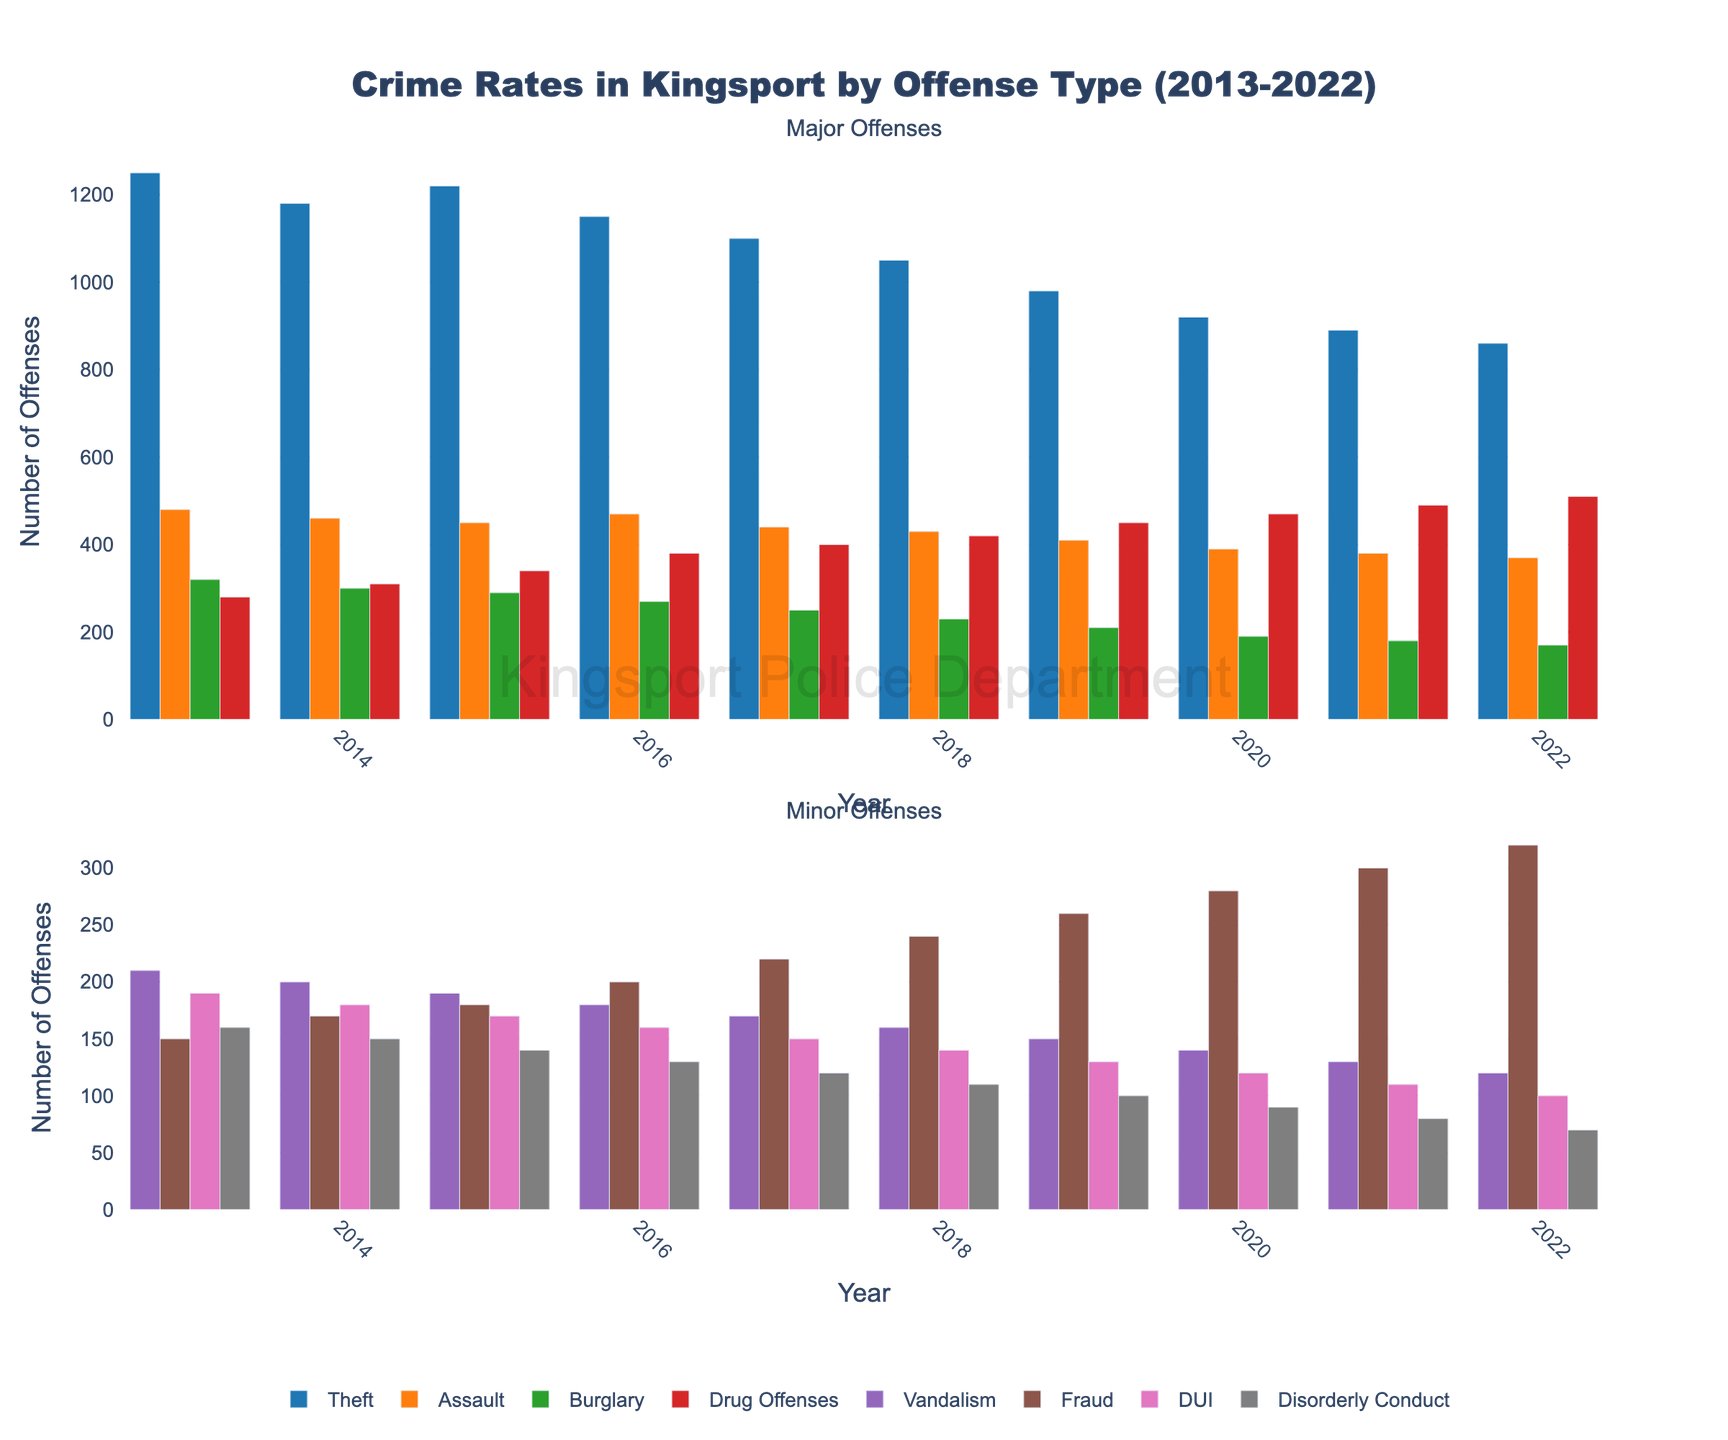What offense type saw the highest total number of offenses from 2013 to 2022? By summing the values for each year from 2013 to 2022 for every offense type, we find that 'Theft' has the highest total number of offenses.
Answer: Theft Which two offense types had the closest number of offenses in 2022? In 2022, the numbers of offenses are: Vandalism (120), Fraud (320), DUI (100), and Disorderly Conduct (70). Comparing these, 'DUI' (100) and 'Disorderly Conduct' (70) have the closest values with a difference of 30 offenses.
Answer: DUI and Disorderly Conduct How did the number of drug offenses change from 2013 to 2022? In 2013, there were 280 drug offenses; by 2022, there were 510. To find the change, subtract the earlier number from the later: 510 - 280 = 230, indicating an increase of 230 offenses.
Answer: Increased by 230 Which offense type showed a consistent decrease every year from 2013 to 2022? By examining each offense type year by year, 'Burglary' consistently decreased every single year from 320 offenses in 2013 to 170 in 2022.
Answer: Burglary In what year did Vandalism drop below 200 offenses for the first time? Observing the values for Vandalism, it dropped below 200 offenses for the first time in 2018, with 160 offenses.
Answer: 2018 What is the average number of DUI offenses over the decade? Sum the DUI values from each year: 190 + 180 + 170 + 160 + 150 + 140 + 130 + 120 + 110 + 100 = 1550. Divide this by the number of years (10): 1550 / 10 = 155.
Answer: 155 How much did the number of fraud offenses increase from 2013 to 2022? In 2013, there were 150 fraud offenses; in 2022, there were 320. Calculate the increase: 320 - 150 = 170.
Answer: Increased by 170 Which year had the highest combined number of major offenses (Theft, Assault, Burglary, Drug Offenses)? Sum the values for Theft, Assault, Burglary, and Drug Offenses for each year. 2013 has the highest combined total: 1250 (Theft) + 480 (Assault) + 320 (Burglary) + 280 (Drug Offenses) = 2330 total offenses.
Answer: 2013 How do the 2022 numbers for Vandalism and Fraud compare? In 2022, Vandalism had 120 offenses, while Fraud had 320 offenses. Fraud has significantly more offenses, with a difference of 200.
Answer: Fraud is higher by 200 offenses 